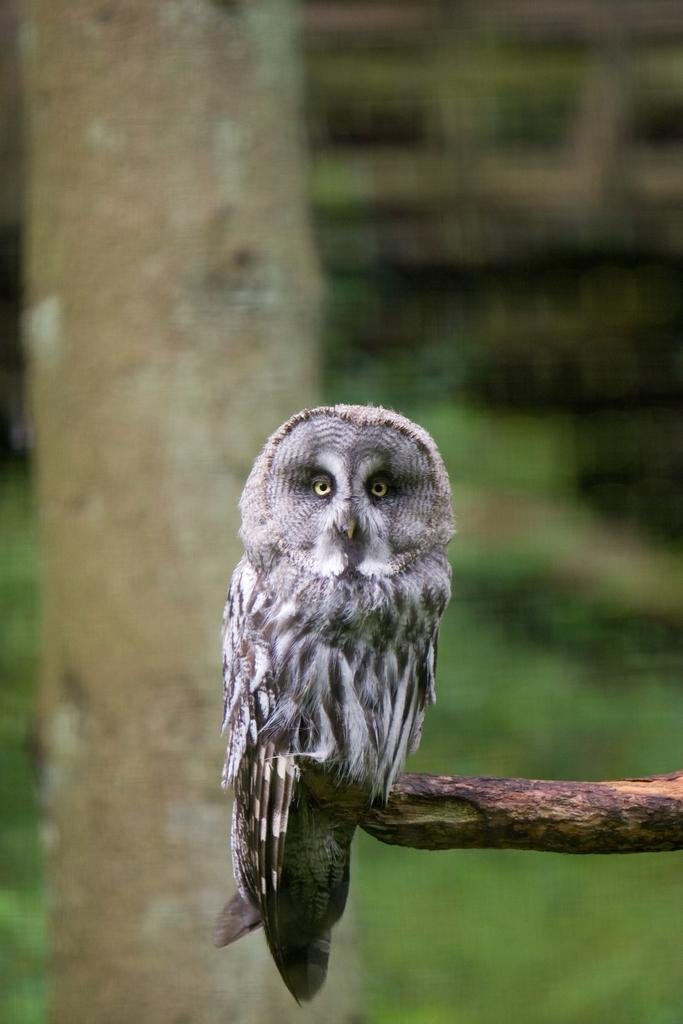What animal can be seen in the picture? There is an owl in the picture. What is the owl standing on? The owl is standing on a wooden stick. What type of vegetation is visible in the image? There is grass visible in the bottom right of the image. What structure is on the left side of the image? There is a tree on the left side of the image. What type of mitten is the owl wearing in the image? The owl is not wearing a mitten in the image; it is an animal and does not wear clothing. 